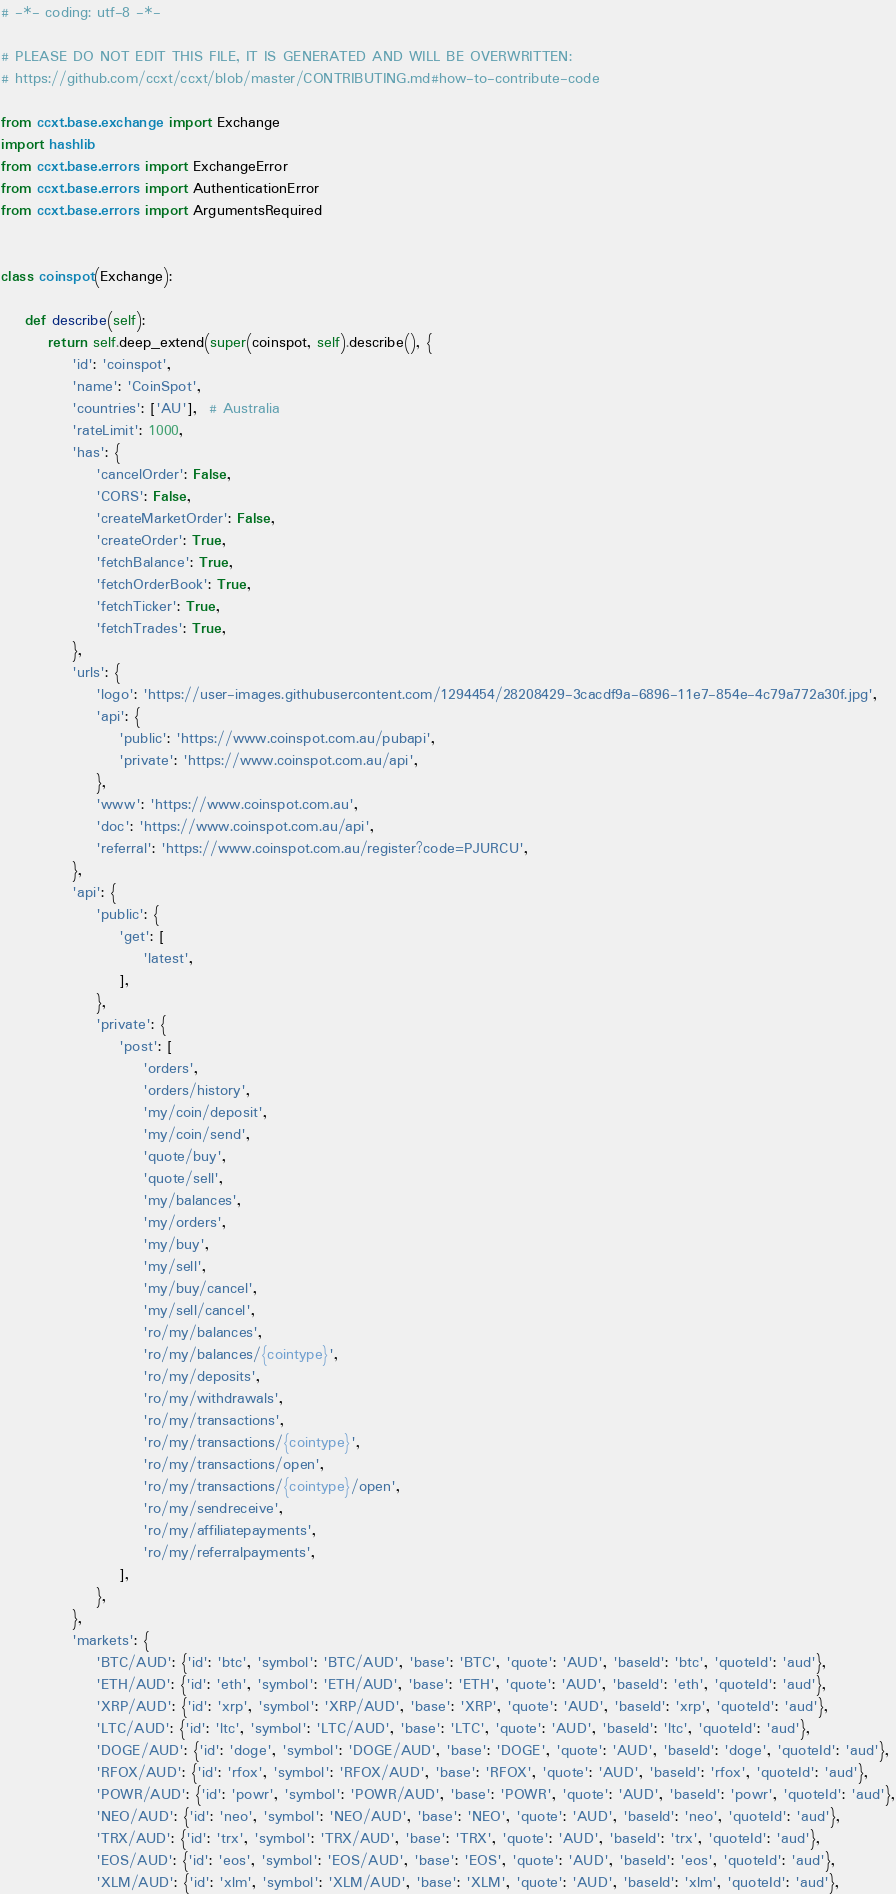Convert code to text. <code><loc_0><loc_0><loc_500><loc_500><_Python_># -*- coding: utf-8 -*-

# PLEASE DO NOT EDIT THIS FILE, IT IS GENERATED AND WILL BE OVERWRITTEN:
# https://github.com/ccxt/ccxt/blob/master/CONTRIBUTING.md#how-to-contribute-code

from ccxt.base.exchange import Exchange
import hashlib
from ccxt.base.errors import ExchangeError
from ccxt.base.errors import AuthenticationError
from ccxt.base.errors import ArgumentsRequired


class coinspot(Exchange):

    def describe(self):
        return self.deep_extend(super(coinspot, self).describe(), {
            'id': 'coinspot',
            'name': 'CoinSpot',
            'countries': ['AU'],  # Australia
            'rateLimit': 1000,
            'has': {
                'cancelOrder': False,
                'CORS': False,
                'createMarketOrder': False,
                'createOrder': True,
                'fetchBalance': True,
                'fetchOrderBook': True,
                'fetchTicker': True,
                'fetchTrades': True,
            },
            'urls': {
                'logo': 'https://user-images.githubusercontent.com/1294454/28208429-3cacdf9a-6896-11e7-854e-4c79a772a30f.jpg',
                'api': {
                    'public': 'https://www.coinspot.com.au/pubapi',
                    'private': 'https://www.coinspot.com.au/api',
                },
                'www': 'https://www.coinspot.com.au',
                'doc': 'https://www.coinspot.com.au/api',
                'referral': 'https://www.coinspot.com.au/register?code=PJURCU',
            },
            'api': {
                'public': {
                    'get': [
                        'latest',
                    ],
                },
                'private': {
                    'post': [
                        'orders',
                        'orders/history',
                        'my/coin/deposit',
                        'my/coin/send',
                        'quote/buy',
                        'quote/sell',
                        'my/balances',
                        'my/orders',
                        'my/buy',
                        'my/sell',
                        'my/buy/cancel',
                        'my/sell/cancel',
                        'ro/my/balances',
                        'ro/my/balances/{cointype}',
                        'ro/my/deposits',
                        'ro/my/withdrawals',
                        'ro/my/transactions',
                        'ro/my/transactions/{cointype}',
                        'ro/my/transactions/open',
                        'ro/my/transactions/{cointype}/open',
                        'ro/my/sendreceive',
                        'ro/my/affiliatepayments',
                        'ro/my/referralpayments',
                    ],
                },
            },
            'markets': {
                'BTC/AUD': {'id': 'btc', 'symbol': 'BTC/AUD', 'base': 'BTC', 'quote': 'AUD', 'baseId': 'btc', 'quoteId': 'aud'},
                'ETH/AUD': {'id': 'eth', 'symbol': 'ETH/AUD', 'base': 'ETH', 'quote': 'AUD', 'baseId': 'eth', 'quoteId': 'aud'},
                'XRP/AUD': {'id': 'xrp', 'symbol': 'XRP/AUD', 'base': 'XRP', 'quote': 'AUD', 'baseId': 'xrp', 'quoteId': 'aud'},
                'LTC/AUD': {'id': 'ltc', 'symbol': 'LTC/AUD', 'base': 'LTC', 'quote': 'AUD', 'baseId': 'ltc', 'quoteId': 'aud'},
                'DOGE/AUD': {'id': 'doge', 'symbol': 'DOGE/AUD', 'base': 'DOGE', 'quote': 'AUD', 'baseId': 'doge', 'quoteId': 'aud'},
                'RFOX/AUD': {'id': 'rfox', 'symbol': 'RFOX/AUD', 'base': 'RFOX', 'quote': 'AUD', 'baseId': 'rfox', 'quoteId': 'aud'},
                'POWR/AUD': {'id': 'powr', 'symbol': 'POWR/AUD', 'base': 'POWR', 'quote': 'AUD', 'baseId': 'powr', 'quoteId': 'aud'},
                'NEO/AUD': {'id': 'neo', 'symbol': 'NEO/AUD', 'base': 'NEO', 'quote': 'AUD', 'baseId': 'neo', 'quoteId': 'aud'},
                'TRX/AUD': {'id': 'trx', 'symbol': 'TRX/AUD', 'base': 'TRX', 'quote': 'AUD', 'baseId': 'trx', 'quoteId': 'aud'},
                'EOS/AUD': {'id': 'eos', 'symbol': 'EOS/AUD', 'base': 'EOS', 'quote': 'AUD', 'baseId': 'eos', 'quoteId': 'aud'},
                'XLM/AUD': {'id': 'xlm', 'symbol': 'XLM/AUD', 'base': 'XLM', 'quote': 'AUD', 'baseId': 'xlm', 'quoteId': 'aud'},</code> 